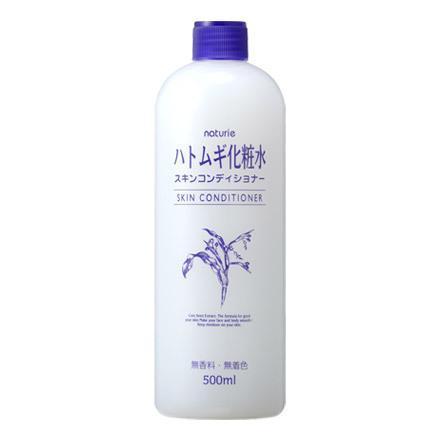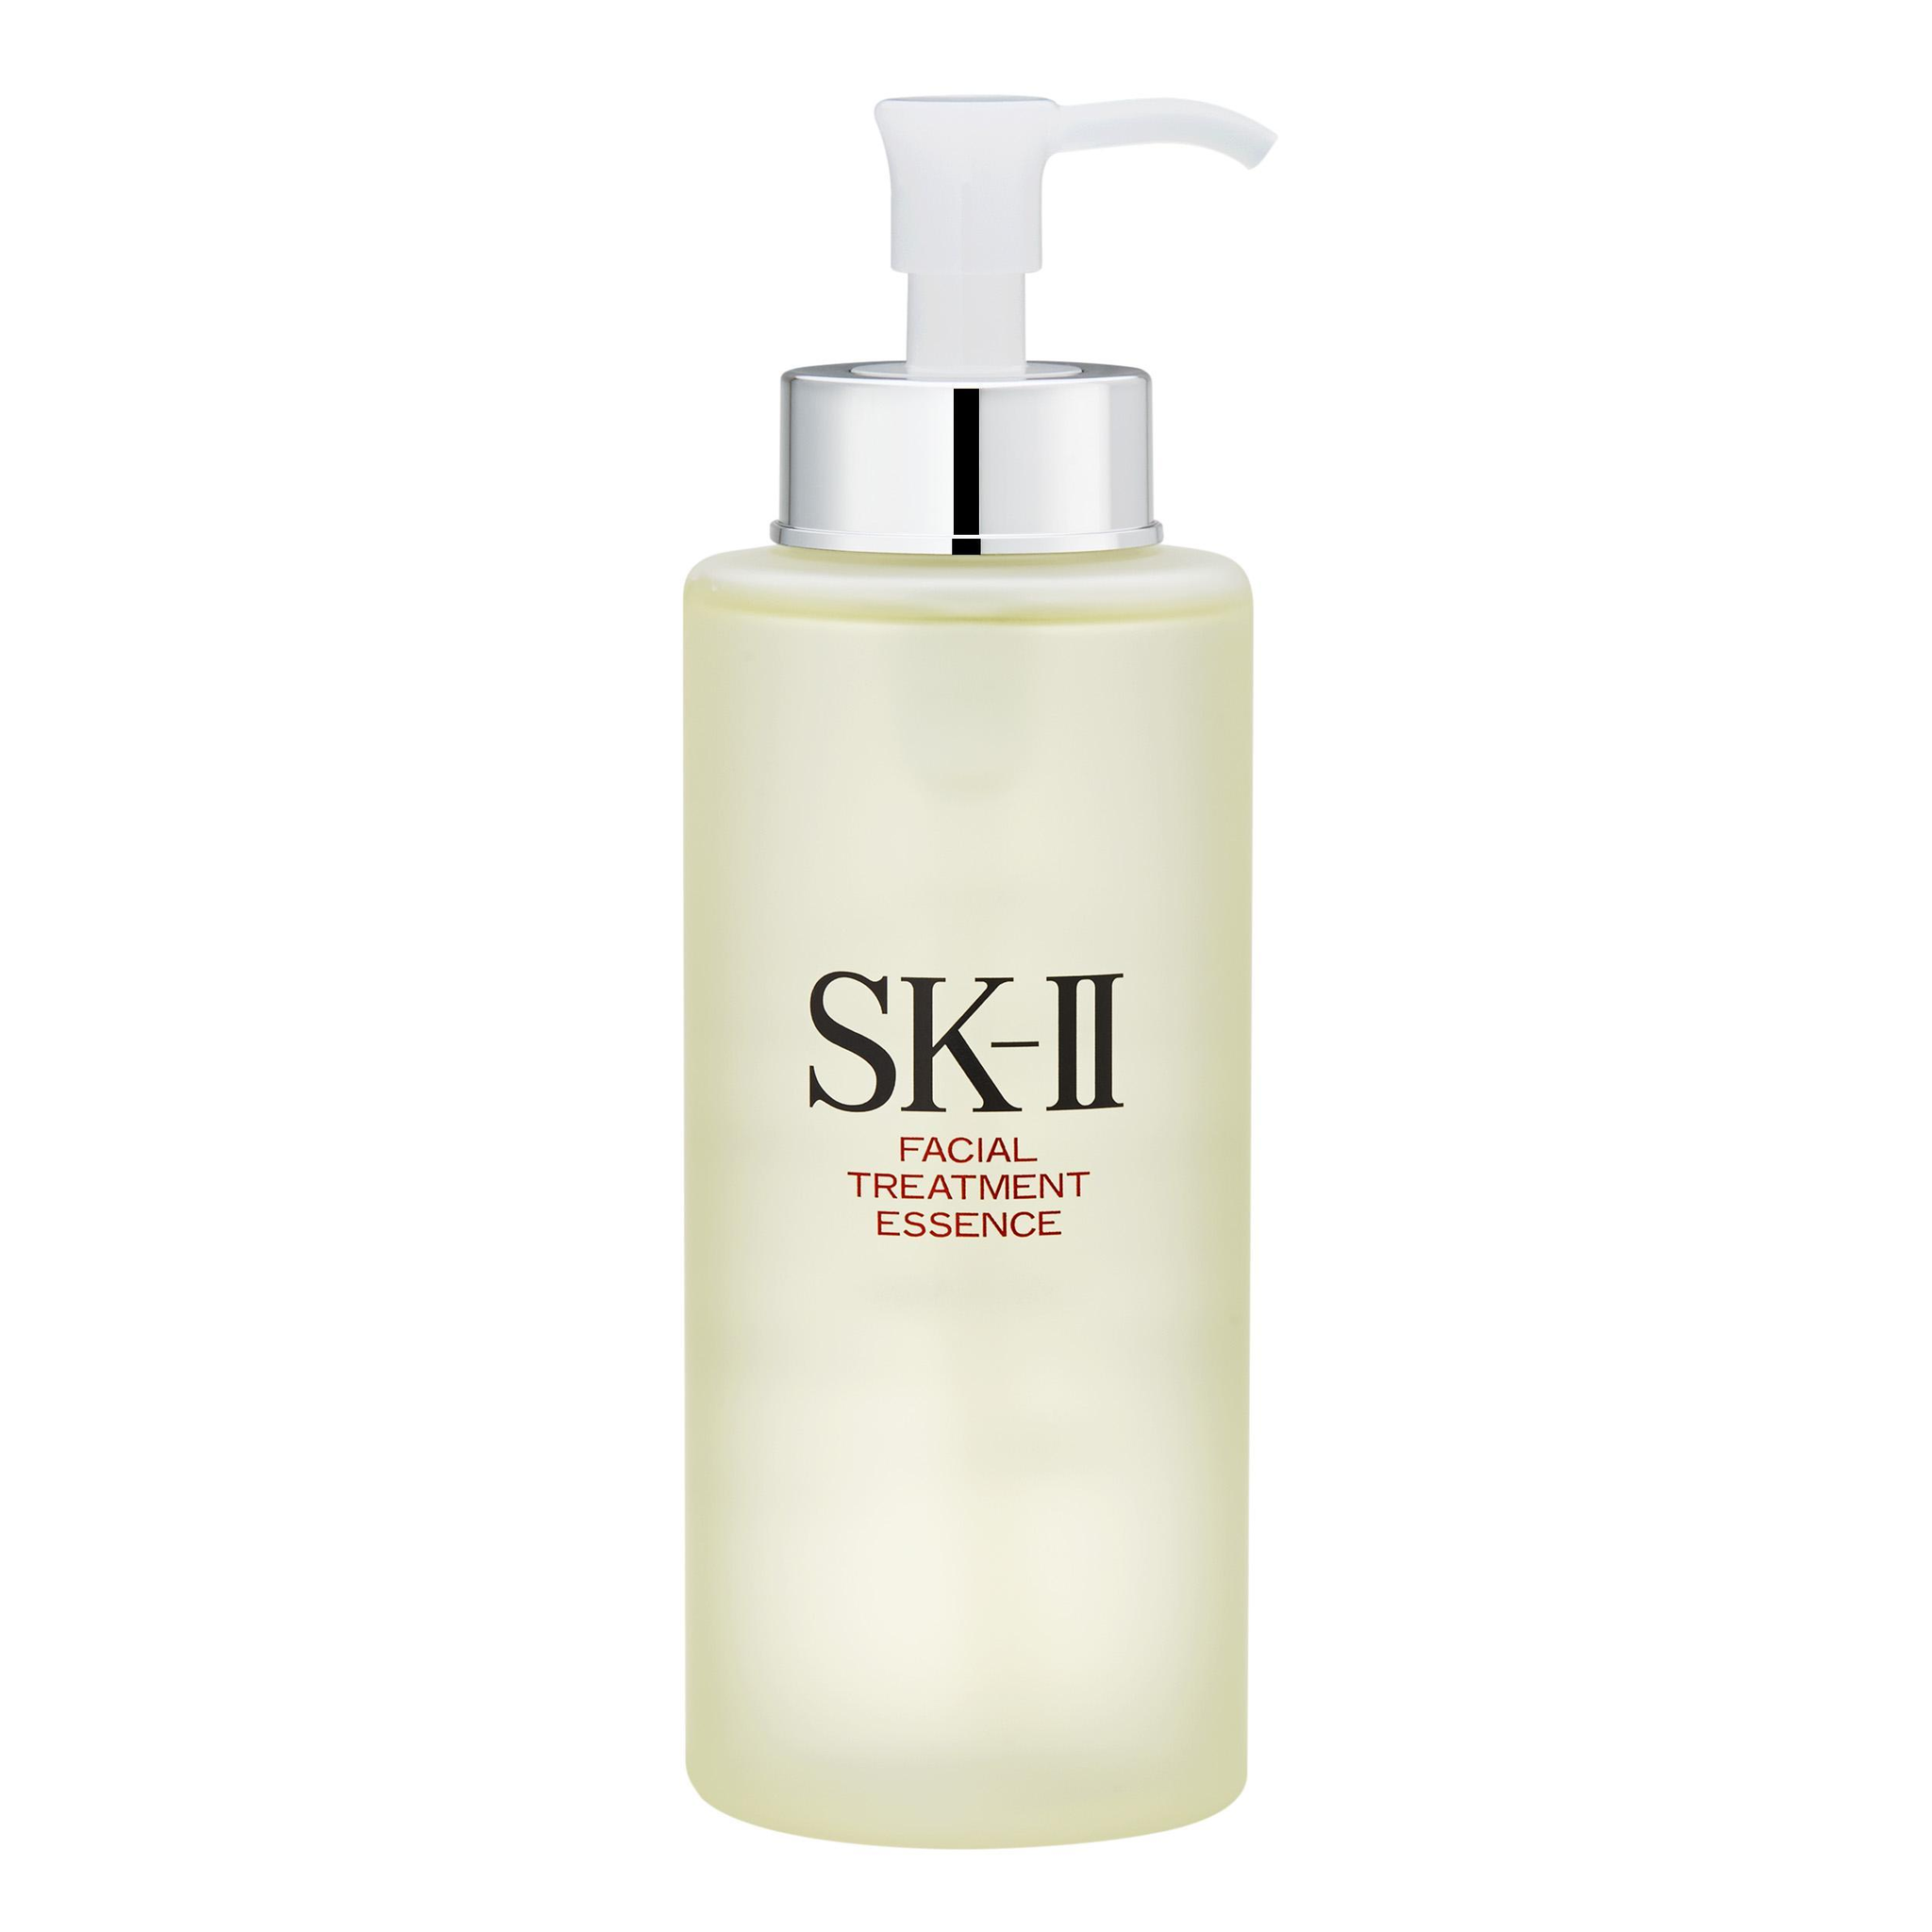The first image is the image on the left, the second image is the image on the right. Given the left and right images, does the statement "The product on the left is in a pump-top bottle with its nozzle turned leftward, and the product on the right does not have a pump-top." hold true? Answer yes or no. No. The first image is the image on the left, the second image is the image on the right. Evaluate the accuracy of this statement regarding the images: "The container in the image on the left has a pump nozzle.". Is it true? Answer yes or no. No. 